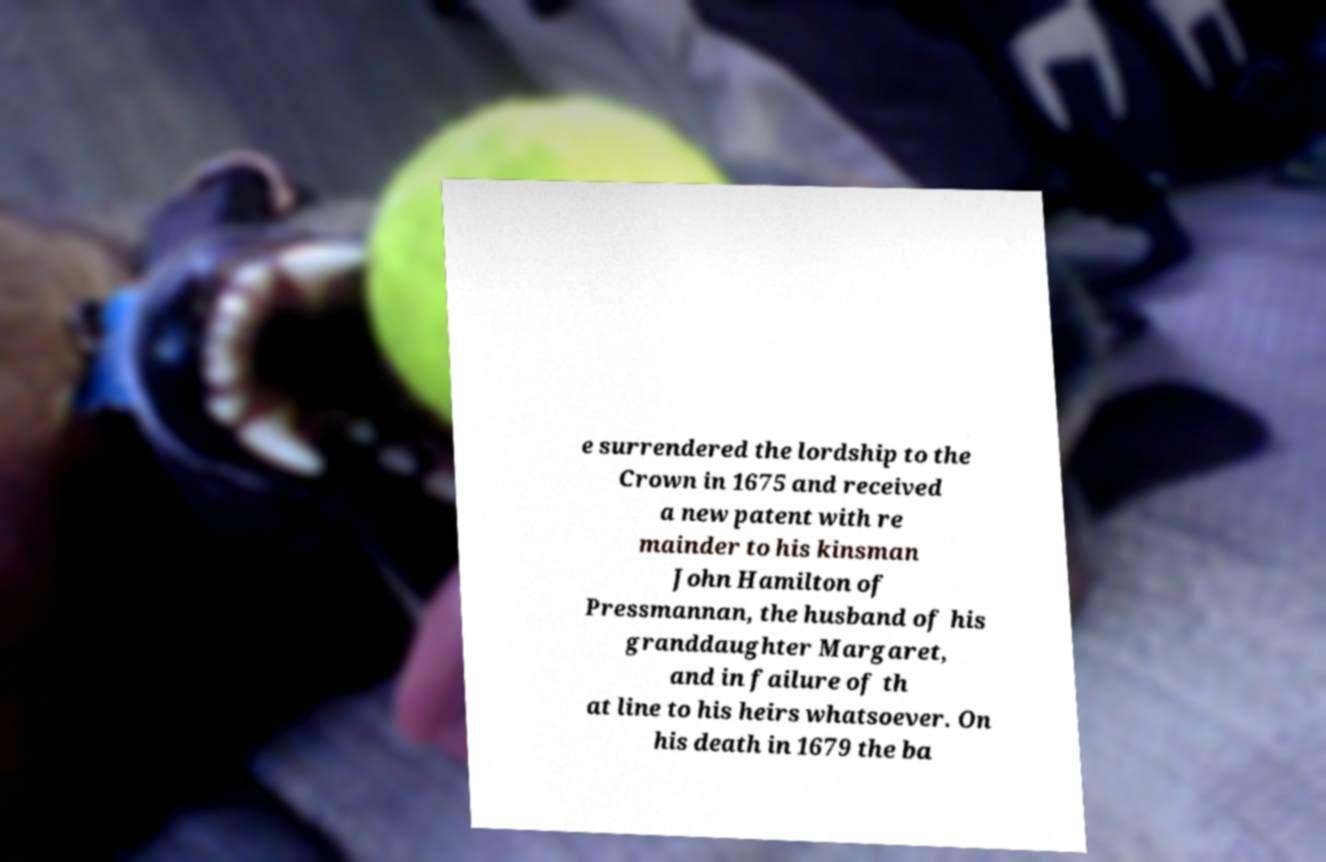There's text embedded in this image that I need extracted. Can you transcribe it verbatim? e surrendered the lordship to the Crown in 1675 and received a new patent with re mainder to his kinsman John Hamilton of Pressmannan, the husband of his granddaughter Margaret, and in failure of th at line to his heirs whatsoever. On his death in 1679 the ba 